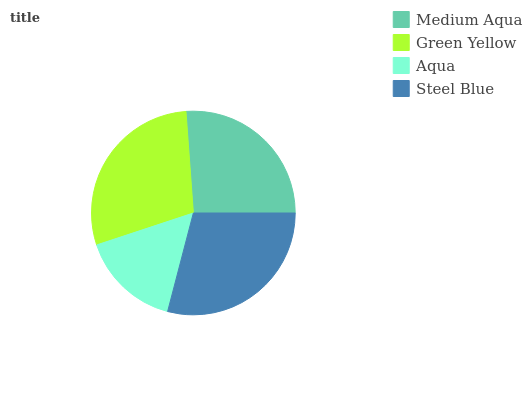Is Aqua the minimum?
Answer yes or no. Yes. Is Steel Blue the maximum?
Answer yes or no. Yes. Is Green Yellow the minimum?
Answer yes or no. No. Is Green Yellow the maximum?
Answer yes or no. No. Is Green Yellow greater than Medium Aqua?
Answer yes or no. Yes. Is Medium Aqua less than Green Yellow?
Answer yes or no. Yes. Is Medium Aqua greater than Green Yellow?
Answer yes or no. No. Is Green Yellow less than Medium Aqua?
Answer yes or no. No. Is Green Yellow the high median?
Answer yes or no. Yes. Is Medium Aqua the low median?
Answer yes or no. Yes. Is Steel Blue the high median?
Answer yes or no. No. Is Green Yellow the low median?
Answer yes or no. No. 